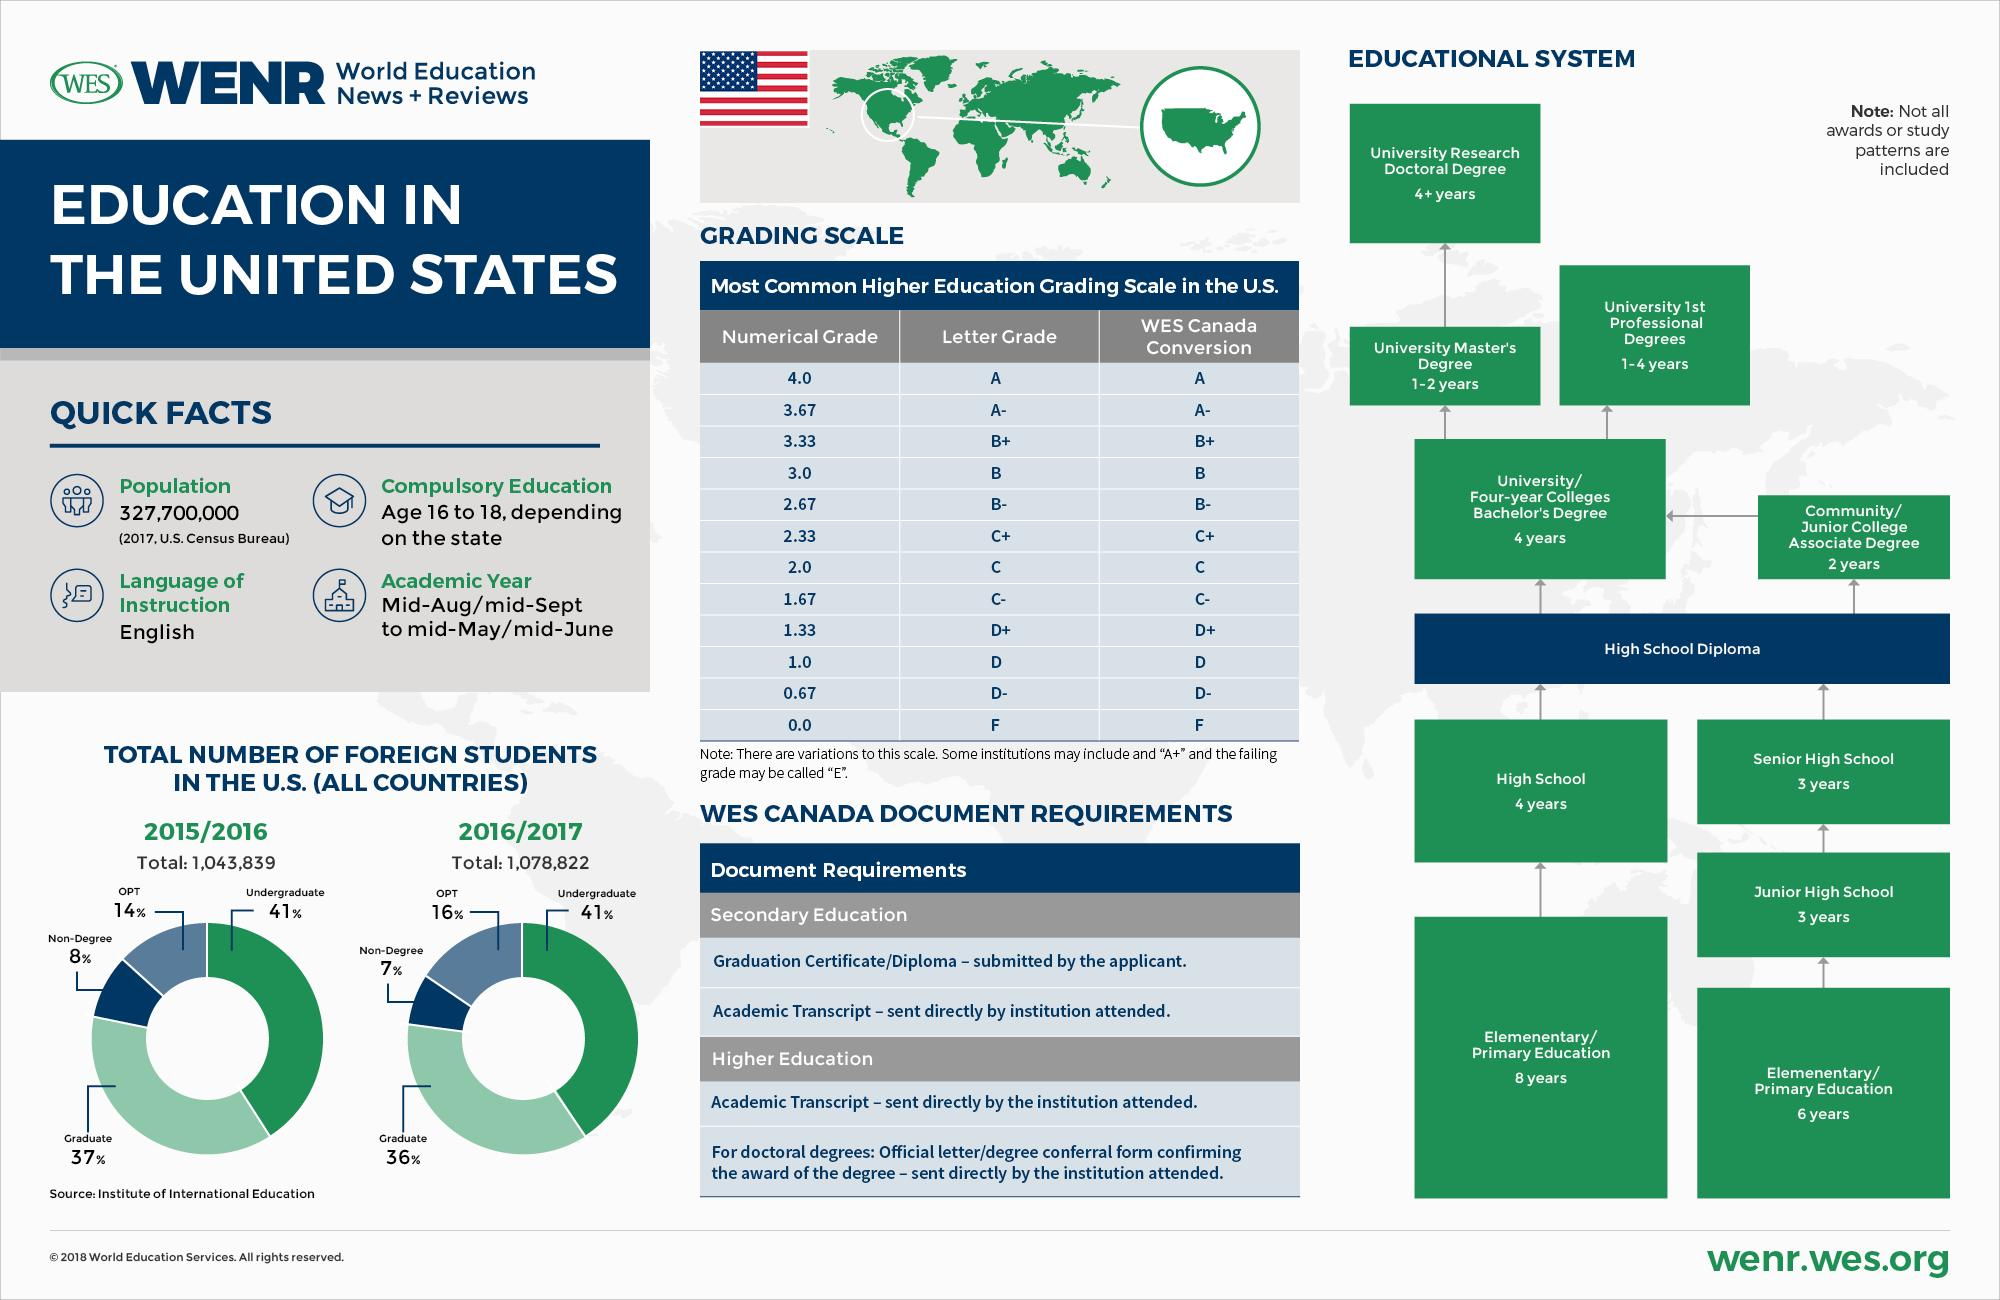Give some essential details in this illustration. In the year 2016/2017, a significant percentage of foreign students in the United States were pursuing a graduate degree, which was roughly 36%. In the academic year 2015/2016, a total of 1,043,839 foreign students were enrolled in institutions of higher education in the United States. In the year 2015/2016, 41% of foreign students in the U.S. were pursuing undergraduate studies. In the year 2016/2017, a total of 1,078,822 foreign students were present in the United States. The lowest letter grade offered in the higher education grading scale in the U.S. is F. 